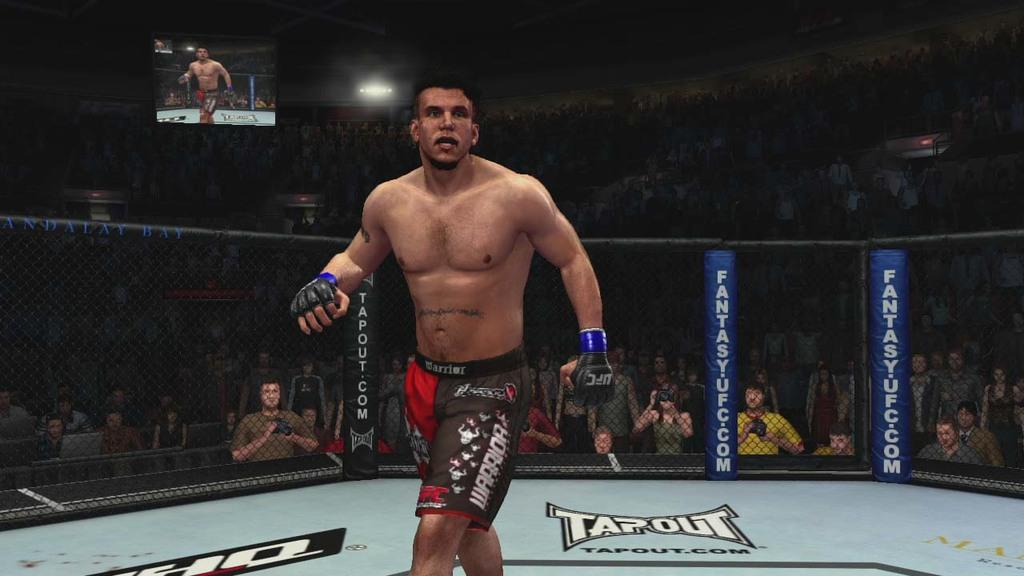Provide a one-sentence caption for the provided image. MMA fighter in a ring that says Tapout on the ground. 